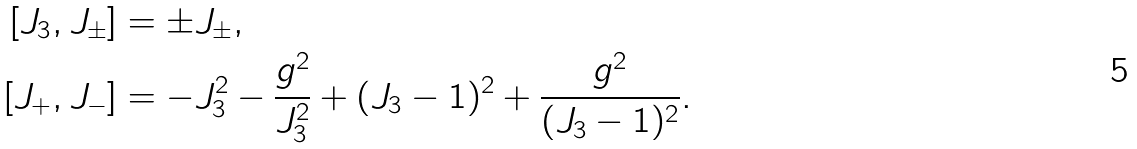<formula> <loc_0><loc_0><loc_500><loc_500>[ J _ { 3 } , J _ { \pm } ] & = \pm J _ { \pm } , \\ [ J _ { + } , J _ { - } ] & = - J _ { 3 } ^ { 2 } - \frac { g ^ { 2 } } { J _ { 3 } ^ { 2 } } + ( J _ { 3 } - 1 ) ^ { 2 } + \frac { g ^ { 2 } } { ( J _ { 3 } - 1 ) ^ { 2 } } .</formula> 